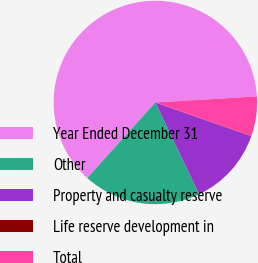<chart> <loc_0><loc_0><loc_500><loc_500><pie_chart><fcel>Year Ended December 31<fcel>Other<fcel>Property and casualty reserve<fcel>Life reserve development in<fcel>Total<nl><fcel>62.37%<fcel>18.75%<fcel>12.52%<fcel>0.06%<fcel>6.29%<nl></chart> 